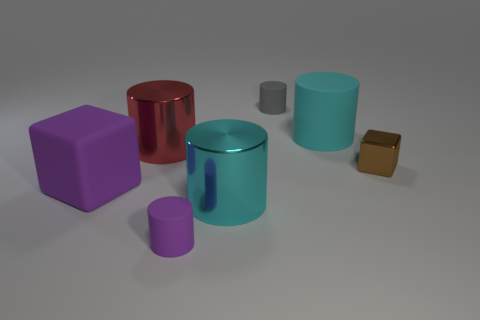Subtract all purple cylinders. How many cylinders are left? 4 Subtract all red cylinders. How many cylinders are left? 4 Subtract all blue cylinders. Subtract all green spheres. How many cylinders are left? 5 Add 3 big purple matte objects. How many objects exist? 10 Subtract all blocks. How many objects are left? 5 Add 3 small cubes. How many small cubes exist? 4 Subtract 0 blue cylinders. How many objects are left? 7 Subtract all gray matte objects. Subtract all cubes. How many objects are left? 4 Add 4 big metal cylinders. How many big metal cylinders are left? 6 